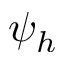Convert formula to latex. <formula><loc_0><loc_0><loc_500><loc_500>\psi _ { h }</formula> 